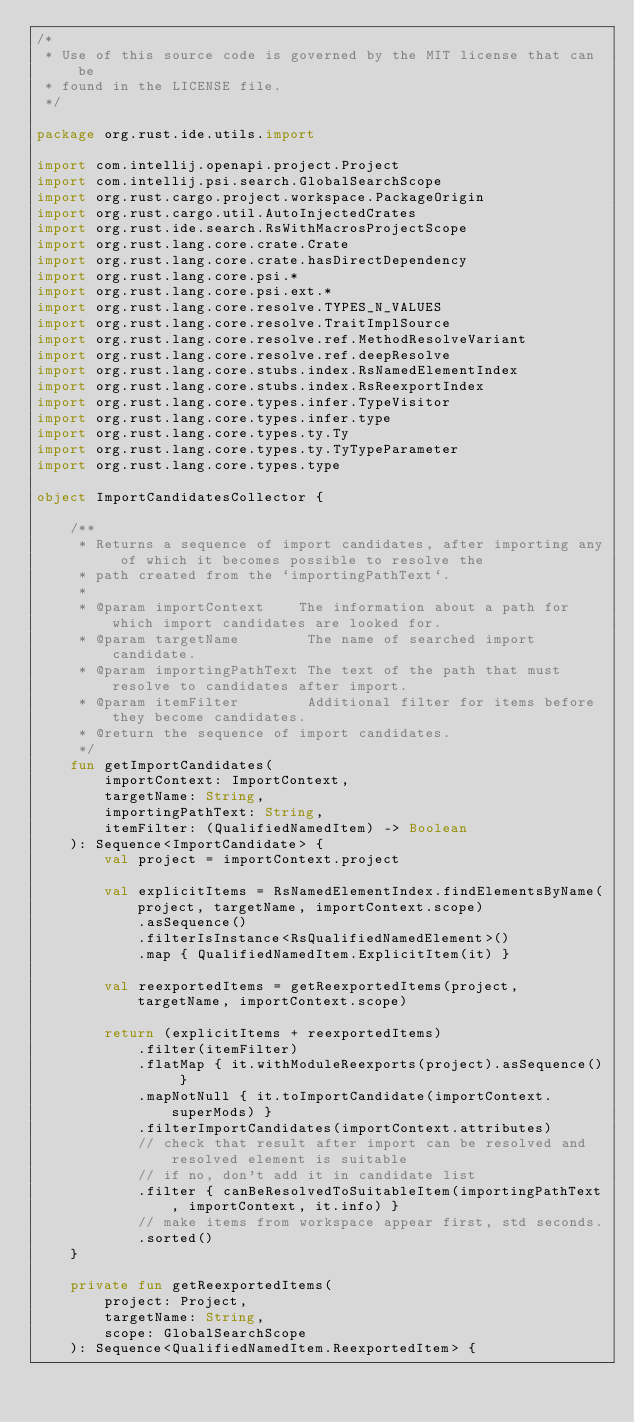<code> <loc_0><loc_0><loc_500><loc_500><_Kotlin_>/*
 * Use of this source code is governed by the MIT license that can be
 * found in the LICENSE file.
 */

package org.rust.ide.utils.import

import com.intellij.openapi.project.Project
import com.intellij.psi.search.GlobalSearchScope
import org.rust.cargo.project.workspace.PackageOrigin
import org.rust.cargo.util.AutoInjectedCrates
import org.rust.ide.search.RsWithMacrosProjectScope
import org.rust.lang.core.crate.Crate
import org.rust.lang.core.crate.hasDirectDependency
import org.rust.lang.core.psi.*
import org.rust.lang.core.psi.ext.*
import org.rust.lang.core.resolve.TYPES_N_VALUES
import org.rust.lang.core.resolve.TraitImplSource
import org.rust.lang.core.resolve.ref.MethodResolveVariant
import org.rust.lang.core.resolve.ref.deepResolve
import org.rust.lang.core.stubs.index.RsNamedElementIndex
import org.rust.lang.core.stubs.index.RsReexportIndex
import org.rust.lang.core.types.infer.TypeVisitor
import org.rust.lang.core.types.infer.type
import org.rust.lang.core.types.ty.Ty
import org.rust.lang.core.types.ty.TyTypeParameter
import org.rust.lang.core.types.type

object ImportCandidatesCollector {

    /**
     * Returns a sequence of import candidates, after importing any of which it becomes possible to resolve the
     * path created from the `importingPathText`.
     *
     * @param importContext    The information about a path for which import candidates are looked for.
     * @param targetName        The name of searched import candidate.
     * @param importingPathText The text of the path that must resolve to candidates after import.
     * @param itemFilter        Additional filter for items before they become candidates.
     * @return the sequence of import candidates.
     */
    fun getImportCandidates(
        importContext: ImportContext,
        targetName: String,
        importingPathText: String,
        itemFilter: (QualifiedNamedItem) -> Boolean
    ): Sequence<ImportCandidate> {
        val project = importContext.project

        val explicitItems = RsNamedElementIndex.findElementsByName(project, targetName, importContext.scope)
            .asSequence()
            .filterIsInstance<RsQualifiedNamedElement>()
            .map { QualifiedNamedItem.ExplicitItem(it) }

        val reexportedItems = getReexportedItems(project, targetName, importContext.scope)

        return (explicitItems + reexportedItems)
            .filter(itemFilter)
            .flatMap { it.withModuleReexports(project).asSequence() }
            .mapNotNull { it.toImportCandidate(importContext.superMods) }
            .filterImportCandidates(importContext.attributes)
            // check that result after import can be resolved and resolved element is suitable
            // if no, don't add it in candidate list
            .filter { canBeResolvedToSuitableItem(importingPathText, importContext, it.info) }
            // make items from workspace appear first, std seconds.
            .sorted()
    }

    private fun getReexportedItems(
        project: Project,
        targetName: String,
        scope: GlobalSearchScope
    ): Sequence<QualifiedNamedItem.ReexportedItem> {</code> 